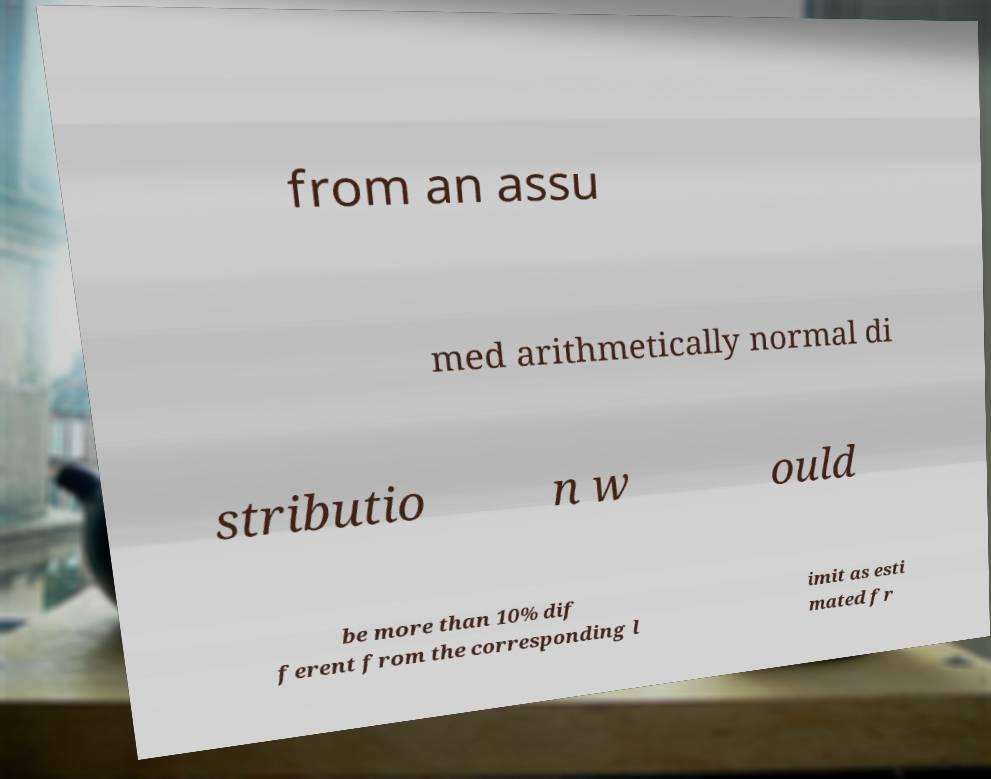For documentation purposes, I need the text within this image transcribed. Could you provide that? from an assu med arithmetically normal di stributio n w ould be more than 10% dif ferent from the corresponding l imit as esti mated fr 